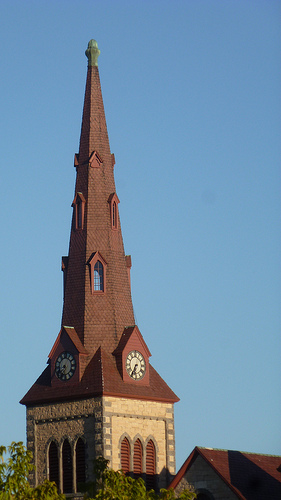What style is the architecture of this building? The building features a gothic revival architectural style, characterized by the pointed arch window designs, ornate detailing, and the tall, narrow spire. 